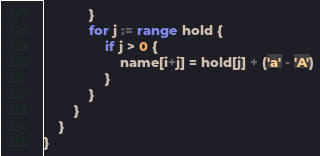<code> <loc_0><loc_0><loc_500><loc_500><_Go_>			}
			for j := range hold {
				if j > 0 {
					name[i+j] = hold[j] + ('a' - 'A')
				}
			}
		}
	}
}

</code> 